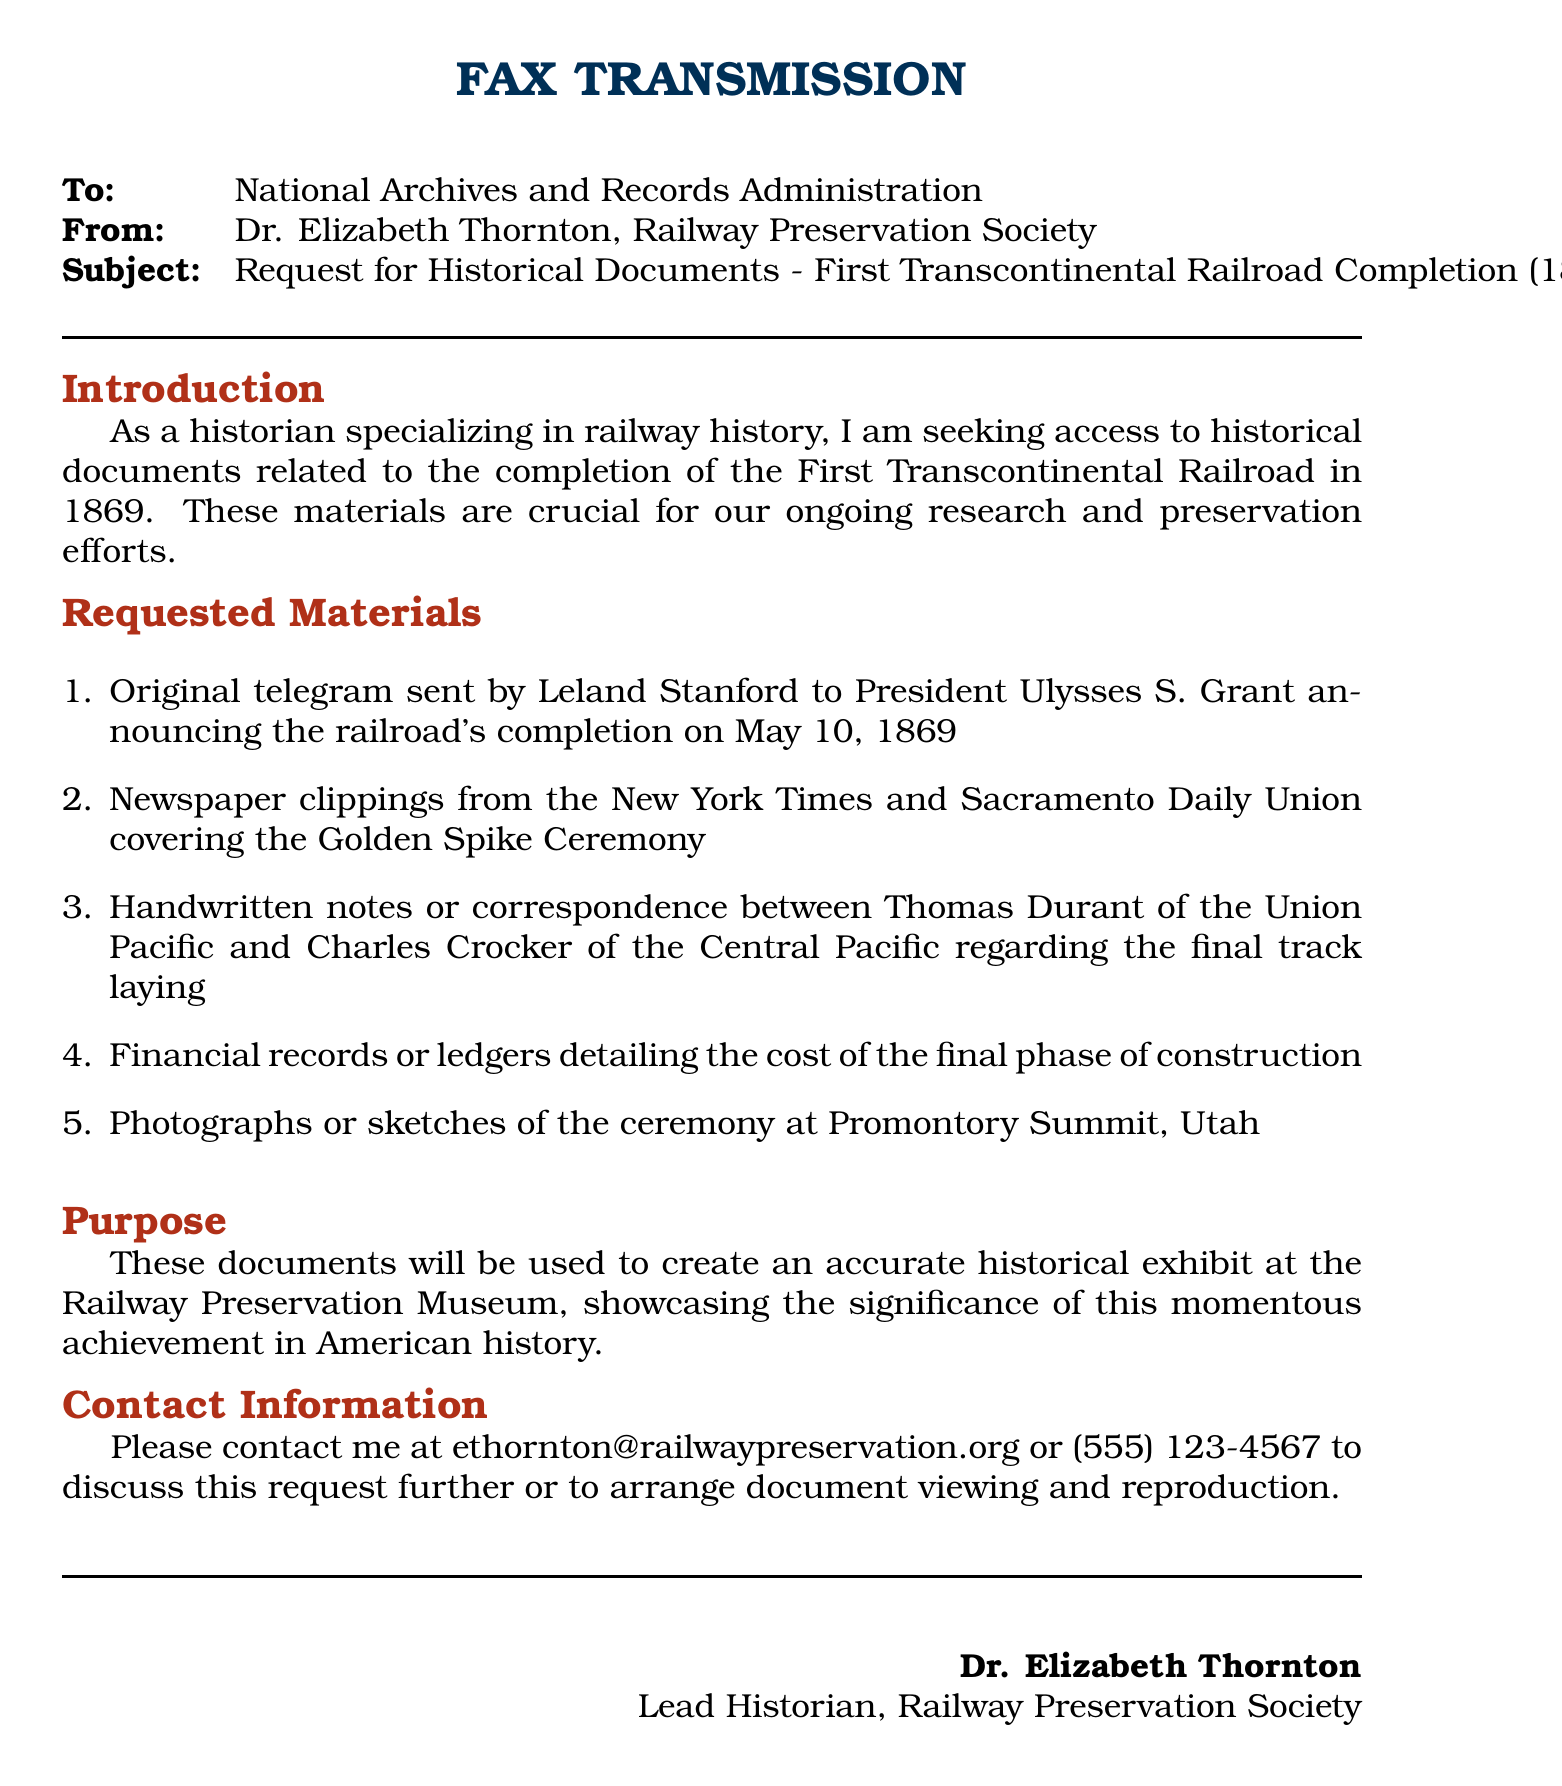what is the date of the completion of the First Transcontinental Railroad? The date mentioned in the document for the completion is May 10, 1869.
Answer: May 10, 1869 who sent the original telegram to President Ulysses S. Grant? The telegram was sent by Leland Stanford, as stated in the request.
Answer: Leland Stanford which two newspapers are cited for covering the Golden Spike Ceremony? The document specifies the New York Times and Sacramento Daily Union as the newspapers involved.
Answer: New York Times and Sacramento Daily Union who were the individuals involved in the final track laying correspondence? Thomas Durant and Charles Crocker are the individuals mentioned in the request for correspondence.
Answer: Thomas Durant and Charles Crocker what is the purpose of requesting these documents? The purpose outlined in the document is to create an accurate historical exhibit at the Railway Preservation Museum.
Answer: Historical exhibit what is the fax's subject line? The subject of the fax is clearly stated regarding the request for historical documents.
Answer: Request for Historical Documents - First Transcontinental Railroad Completion (1869) how can the sender of the fax be contacted? The document provides an email and a phone number for further communication regarding the request.
Answer: ethornton@railwaypreservation.org or (555) 123-4567 what title does Dr. Elizabeth Thornton hold? The title mentioned for Dr. Elizabeth Thornton in the document is Lead Historian.
Answer: Lead Historian 